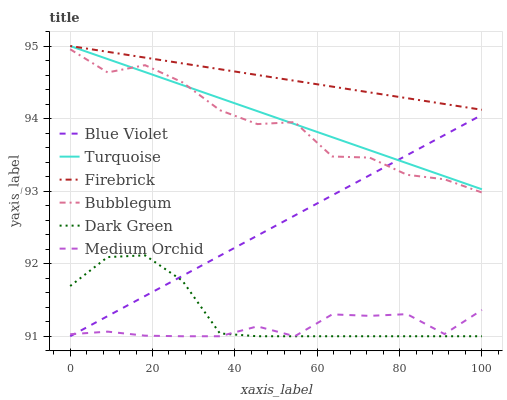Does Medium Orchid have the minimum area under the curve?
Answer yes or no. Yes. Does Firebrick have the maximum area under the curve?
Answer yes or no. Yes. Does Firebrick have the minimum area under the curve?
Answer yes or no. No. Does Medium Orchid have the maximum area under the curve?
Answer yes or no. No. Is Firebrick the smoothest?
Answer yes or no. Yes. Is Bubblegum the roughest?
Answer yes or no. Yes. Is Medium Orchid the smoothest?
Answer yes or no. No. Is Medium Orchid the roughest?
Answer yes or no. No. Does Medium Orchid have the lowest value?
Answer yes or no. Yes. Does Firebrick have the lowest value?
Answer yes or no. No. Does Firebrick have the highest value?
Answer yes or no. Yes. Does Medium Orchid have the highest value?
Answer yes or no. No. Is Dark Green less than Turquoise?
Answer yes or no. Yes. Is Turquoise greater than Dark Green?
Answer yes or no. Yes. Does Turquoise intersect Firebrick?
Answer yes or no. Yes. Is Turquoise less than Firebrick?
Answer yes or no. No. Is Turquoise greater than Firebrick?
Answer yes or no. No. Does Dark Green intersect Turquoise?
Answer yes or no. No. 